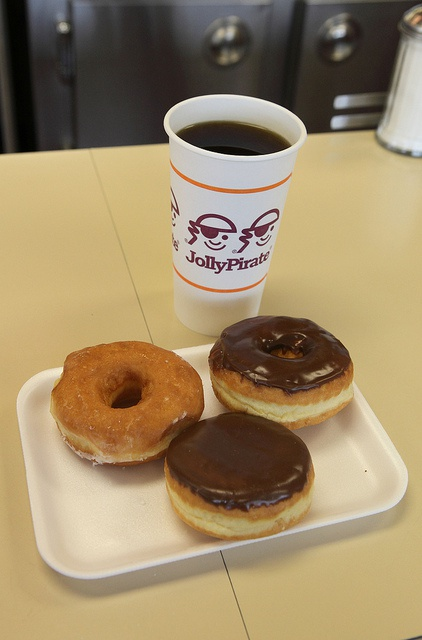Describe the objects in this image and their specific colors. I can see dining table in tan and black tones, cup in black, lightgray, and darkgray tones, donut in black, red, maroon, tan, and gray tones, donut in black, maroon, tan, and olive tones, and donut in black, maroon, olive, and tan tones in this image. 